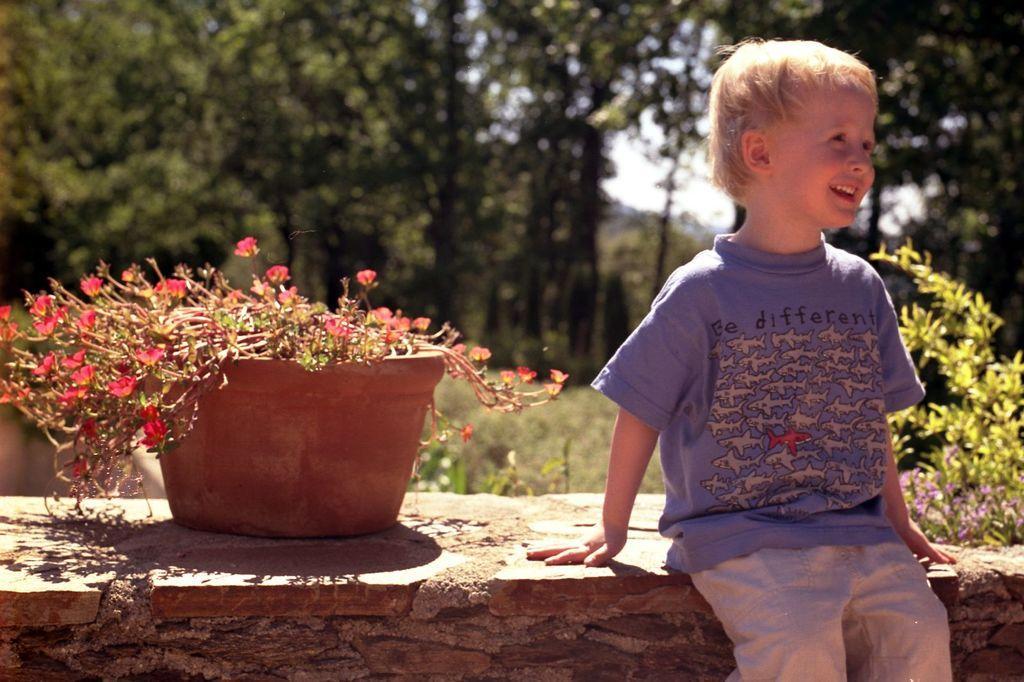Describe this image in one or two sentences. In this image there is a child sitting on a wall, on that wall there is a pot, in the background there are trees. 